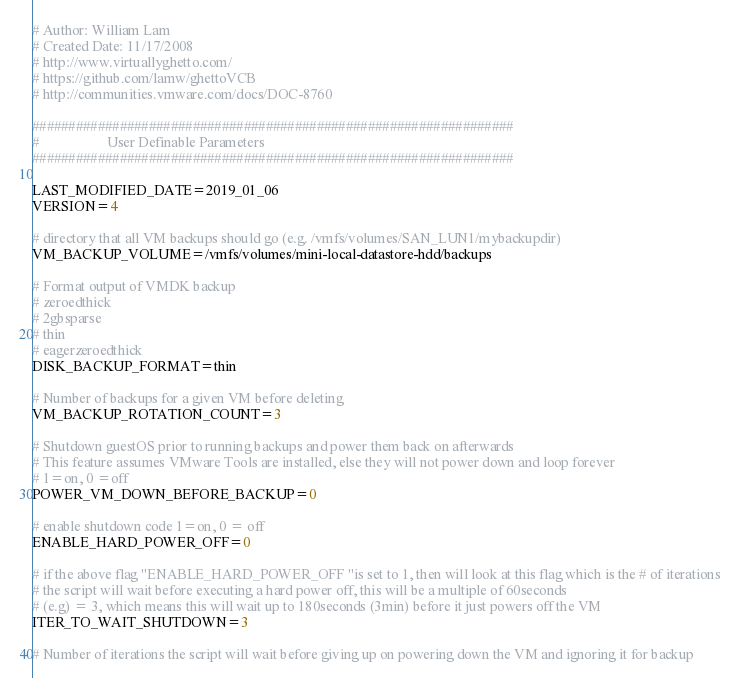<code> <loc_0><loc_0><loc_500><loc_500><_Bash_># Author: William Lam
# Created Date: 11/17/2008
# http://www.virtuallyghetto.com/
# https://github.com/lamw/ghettoVCB
# http://communities.vmware.com/docs/DOC-8760

##################################################################
#                   User Definable Parameters
##################################################################

LAST_MODIFIED_DATE=2019_01_06
VERSION=4

# directory that all VM backups should go (e.g. /vmfs/volumes/SAN_LUN1/mybackupdir)
VM_BACKUP_VOLUME=/vmfs/volumes/mini-local-datastore-hdd/backups

# Format output of VMDK backup
# zeroedthick
# 2gbsparse
# thin
# eagerzeroedthick
DISK_BACKUP_FORMAT=thin

# Number of backups for a given VM before deleting
VM_BACKUP_ROTATION_COUNT=3

# Shutdown guestOS prior to running backups and power them back on afterwards
# This feature assumes VMware Tools are installed, else they will not power down and loop forever
# 1=on, 0 =off
POWER_VM_DOWN_BEFORE_BACKUP=0

# enable shutdown code 1=on, 0 = off
ENABLE_HARD_POWER_OFF=0

# if the above flag "ENABLE_HARD_POWER_OFF "is set to 1, then will look at this flag which is the # of iterations
# the script will wait before executing a hard power off, this will be a multiple of 60seconds
# (e.g) = 3, which means this will wait up to 180seconds (3min) before it just powers off the VM
ITER_TO_WAIT_SHUTDOWN=3

# Number of iterations the script will wait before giving up on powering down the VM and ignoring it for backup</code> 